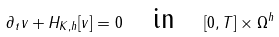Convert formula to latex. <formula><loc_0><loc_0><loc_500><loc_500>\partial _ { t } v + H _ { K , h } [ v ] = 0 \quad \text {in} \quad [ 0 , T ] \times \Omega ^ { h }</formula> 